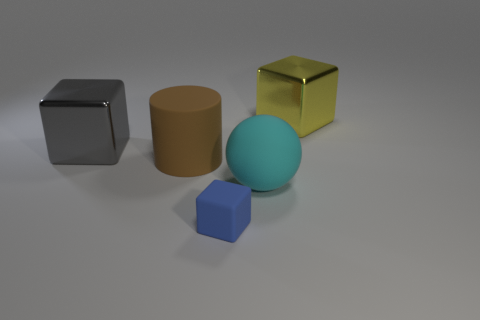Subtract all tiny blue rubber cubes. How many cubes are left? 2 Add 2 rubber balls. How many objects exist? 7 Subtract 1 cubes. How many cubes are left? 2 Subtract all cylinders. How many objects are left? 4 Subtract all green spheres. Subtract all green cylinders. How many spheres are left? 1 Subtract all spheres. Subtract all blue rubber blocks. How many objects are left? 3 Add 5 large yellow cubes. How many large yellow cubes are left? 6 Add 5 small things. How many small things exist? 6 Subtract all gray blocks. How many blocks are left? 2 Subtract 0 brown spheres. How many objects are left? 5 